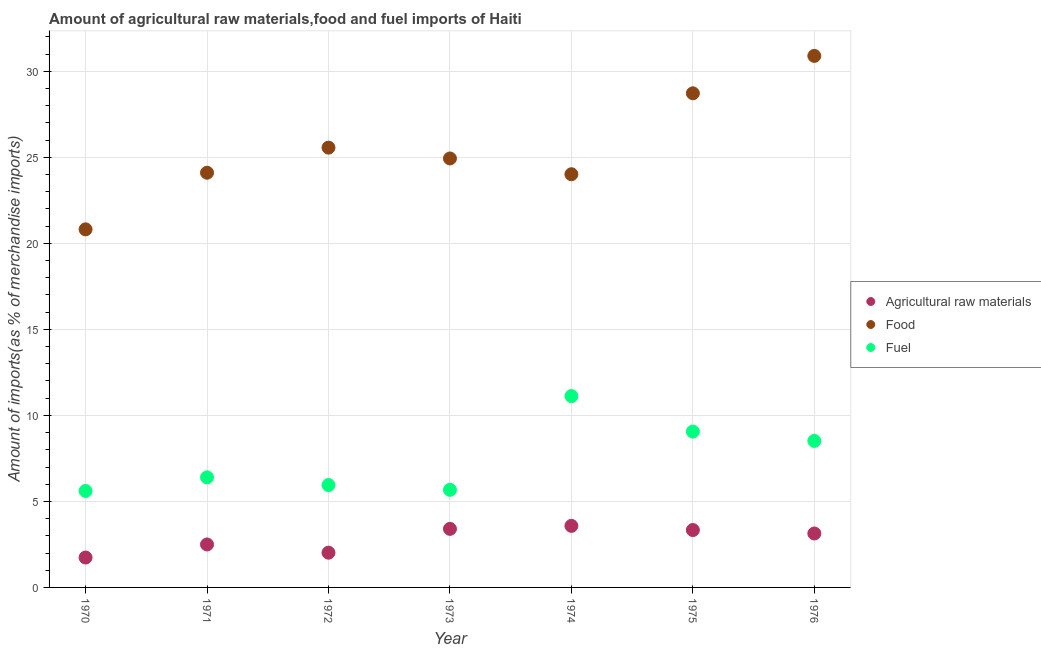How many different coloured dotlines are there?
Your answer should be compact. 3. What is the percentage of fuel imports in 1973?
Your answer should be compact. 5.67. Across all years, what is the maximum percentage of food imports?
Ensure brevity in your answer.  30.9. Across all years, what is the minimum percentage of food imports?
Your answer should be very brief. 20.81. In which year was the percentage of food imports maximum?
Your answer should be very brief. 1976. What is the total percentage of raw materials imports in the graph?
Provide a short and direct response. 19.71. What is the difference between the percentage of fuel imports in 1970 and that in 1974?
Provide a short and direct response. -5.51. What is the difference between the percentage of fuel imports in 1974 and the percentage of raw materials imports in 1973?
Give a very brief answer. 7.72. What is the average percentage of raw materials imports per year?
Keep it short and to the point. 2.82. In the year 1970, what is the difference between the percentage of fuel imports and percentage of raw materials imports?
Provide a succinct answer. 3.87. In how many years, is the percentage of raw materials imports greater than 6 %?
Offer a terse response. 0. What is the ratio of the percentage of food imports in 1973 to that in 1975?
Offer a very short reply. 0.87. What is the difference between the highest and the second highest percentage of food imports?
Your response must be concise. 2.17. What is the difference between the highest and the lowest percentage of raw materials imports?
Make the answer very short. 1.84. In how many years, is the percentage of food imports greater than the average percentage of food imports taken over all years?
Give a very brief answer. 2. Does the percentage of food imports monotonically increase over the years?
Keep it short and to the point. No. Is the percentage of food imports strictly less than the percentage of fuel imports over the years?
Keep it short and to the point. No. Are the values on the major ticks of Y-axis written in scientific E-notation?
Ensure brevity in your answer.  No. Where does the legend appear in the graph?
Make the answer very short. Center right. How many legend labels are there?
Offer a very short reply. 3. How are the legend labels stacked?
Your answer should be very brief. Vertical. What is the title of the graph?
Your answer should be compact. Amount of agricultural raw materials,food and fuel imports of Haiti. What is the label or title of the X-axis?
Your answer should be compact. Year. What is the label or title of the Y-axis?
Provide a short and direct response. Amount of imports(as % of merchandise imports). What is the Amount of imports(as % of merchandise imports) in Agricultural raw materials in 1970?
Make the answer very short. 1.74. What is the Amount of imports(as % of merchandise imports) of Food in 1970?
Keep it short and to the point. 20.81. What is the Amount of imports(as % of merchandise imports) in Fuel in 1970?
Ensure brevity in your answer.  5.61. What is the Amount of imports(as % of merchandise imports) of Agricultural raw materials in 1971?
Give a very brief answer. 2.5. What is the Amount of imports(as % of merchandise imports) in Food in 1971?
Provide a succinct answer. 24.11. What is the Amount of imports(as % of merchandise imports) in Fuel in 1971?
Give a very brief answer. 6.4. What is the Amount of imports(as % of merchandise imports) in Agricultural raw materials in 1972?
Offer a very short reply. 2.02. What is the Amount of imports(as % of merchandise imports) in Food in 1972?
Offer a terse response. 25.56. What is the Amount of imports(as % of merchandise imports) in Fuel in 1972?
Keep it short and to the point. 5.95. What is the Amount of imports(as % of merchandise imports) in Agricultural raw materials in 1973?
Make the answer very short. 3.4. What is the Amount of imports(as % of merchandise imports) in Food in 1973?
Your answer should be compact. 24.94. What is the Amount of imports(as % of merchandise imports) in Fuel in 1973?
Make the answer very short. 5.67. What is the Amount of imports(as % of merchandise imports) of Agricultural raw materials in 1974?
Ensure brevity in your answer.  3.58. What is the Amount of imports(as % of merchandise imports) in Food in 1974?
Provide a succinct answer. 24.02. What is the Amount of imports(as % of merchandise imports) in Fuel in 1974?
Ensure brevity in your answer.  11.12. What is the Amount of imports(as % of merchandise imports) of Agricultural raw materials in 1975?
Keep it short and to the point. 3.34. What is the Amount of imports(as % of merchandise imports) in Food in 1975?
Keep it short and to the point. 28.72. What is the Amount of imports(as % of merchandise imports) of Fuel in 1975?
Your answer should be very brief. 9.06. What is the Amount of imports(as % of merchandise imports) in Agricultural raw materials in 1976?
Offer a terse response. 3.14. What is the Amount of imports(as % of merchandise imports) in Food in 1976?
Give a very brief answer. 30.9. What is the Amount of imports(as % of merchandise imports) of Fuel in 1976?
Offer a very short reply. 8.52. Across all years, what is the maximum Amount of imports(as % of merchandise imports) in Agricultural raw materials?
Provide a short and direct response. 3.58. Across all years, what is the maximum Amount of imports(as % of merchandise imports) in Food?
Keep it short and to the point. 30.9. Across all years, what is the maximum Amount of imports(as % of merchandise imports) in Fuel?
Your answer should be compact. 11.12. Across all years, what is the minimum Amount of imports(as % of merchandise imports) in Agricultural raw materials?
Your answer should be very brief. 1.74. Across all years, what is the minimum Amount of imports(as % of merchandise imports) of Food?
Make the answer very short. 20.81. Across all years, what is the minimum Amount of imports(as % of merchandise imports) of Fuel?
Provide a short and direct response. 5.61. What is the total Amount of imports(as % of merchandise imports) in Agricultural raw materials in the graph?
Your answer should be compact. 19.71. What is the total Amount of imports(as % of merchandise imports) of Food in the graph?
Make the answer very short. 179.06. What is the total Amount of imports(as % of merchandise imports) of Fuel in the graph?
Your response must be concise. 52.33. What is the difference between the Amount of imports(as % of merchandise imports) in Agricultural raw materials in 1970 and that in 1971?
Ensure brevity in your answer.  -0.76. What is the difference between the Amount of imports(as % of merchandise imports) of Food in 1970 and that in 1971?
Your response must be concise. -3.29. What is the difference between the Amount of imports(as % of merchandise imports) of Fuel in 1970 and that in 1971?
Your answer should be compact. -0.79. What is the difference between the Amount of imports(as % of merchandise imports) of Agricultural raw materials in 1970 and that in 1972?
Keep it short and to the point. -0.28. What is the difference between the Amount of imports(as % of merchandise imports) in Food in 1970 and that in 1972?
Keep it short and to the point. -4.75. What is the difference between the Amount of imports(as % of merchandise imports) of Fuel in 1970 and that in 1972?
Your answer should be very brief. -0.34. What is the difference between the Amount of imports(as % of merchandise imports) of Agricultural raw materials in 1970 and that in 1973?
Make the answer very short. -1.67. What is the difference between the Amount of imports(as % of merchandise imports) in Food in 1970 and that in 1973?
Your answer should be very brief. -4.12. What is the difference between the Amount of imports(as % of merchandise imports) in Fuel in 1970 and that in 1973?
Ensure brevity in your answer.  -0.07. What is the difference between the Amount of imports(as % of merchandise imports) in Agricultural raw materials in 1970 and that in 1974?
Provide a succinct answer. -1.84. What is the difference between the Amount of imports(as % of merchandise imports) in Food in 1970 and that in 1974?
Keep it short and to the point. -3.2. What is the difference between the Amount of imports(as % of merchandise imports) in Fuel in 1970 and that in 1974?
Keep it short and to the point. -5.51. What is the difference between the Amount of imports(as % of merchandise imports) of Agricultural raw materials in 1970 and that in 1975?
Give a very brief answer. -1.6. What is the difference between the Amount of imports(as % of merchandise imports) in Food in 1970 and that in 1975?
Offer a very short reply. -7.91. What is the difference between the Amount of imports(as % of merchandise imports) in Fuel in 1970 and that in 1975?
Make the answer very short. -3.45. What is the difference between the Amount of imports(as % of merchandise imports) of Agricultural raw materials in 1970 and that in 1976?
Offer a very short reply. -1.4. What is the difference between the Amount of imports(as % of merchandise imports) of Food in 1970 and that in 1976?
Your response must be concise. -10.08. What is the difference between the Amount of imports(as % of merchandise imports) of Fuel in 1970 and that in 1976?
Ensure brevity in your answer.  -2.91. What is the difference between the Amount of imports(as % of merchandise imports) in Agricultural raw materials in 1971 and that in 1972?
Offer a very short reply. 0.48. What is the difference between the Amount of imports(as % of merchandise imports) in Food in 1971 and that in 1972?
Offer a terse response. -1.46. What is the difference between the Amount of imports(as % of merchandise imports) of Fuel in 1971 and that in 1972?
Offer a terse response. 0.45. What is the difference between the Amount of imports(as % of merchandise imports) of Agricultural raw materials in 1971 and that in 1973?
Offer a very short reply. -0.91. What is the difference between the Amount of imports(as % of merchandise imports) in Food in 1971 and that in 1973?
Ensure brevity in your answer.  -0.83. What is the difference between the Amount of imports(as % of merchandise imports) of Fuel in 1971 and that in 1973?
Your answer should be very brief. 0.72. What is the difference between the Amount of imports(as % of merchandise imports) in Agricultural raw materials in 1971 and that in 1974?
Your response must be concise. -1.08. What is the difference between the Amount of imports(as % of merchandise imports) in Food in 1971 and that in 1974?
Offer a very short reply. 0.09. What is the difference between the Amount of imports(as % of merchandise imports) in Fuel in 1971 and that in 1974?
Offer a terse response. -4.73. What is the difference between the Amount of imports(as % of merchandise imports) of Agricultural raw materials in 1971 and that in 1975?
Your answer should be very brief. -0.84. What is the difference between the Amount of imports(as % of merchandise imports) of Food in 1971 and that in 1975?
Keep it short and to the point. -4.62. What is the difference between the Amount of imports(as % of merchandise imports) in Fuel in 1971 and that in 1975?
Offer a very short reply. -2.66. What is the difference between the Amount of imports(as % of merchandise imports) of Agricultural raw materials in 1971 and that in 1976?
Provide a succinct answer. -0.64. What is the difference between the Amount of imports(as % of merchandise imports) in Food in 1971 and that in 1976?
Keep it short and to the point. -6.79. What is the difference between the Amount of imports(as % of merchandise imports) in Fuel in 1971 and that in 1976?
Give a very brief answer. -2.12. What is the difference between the Amount of imports(as % of merchandise imports) in Agricultural raw materials in 1972 and that in 1973?
Offer a very short reply. -1.39. What is the difference between the Amount of imports(as % of merchandise imports) of Food in 1972 and that in 1973?
Keep it short and to the point. 0.63. What is the difference between the Amount of imports(as % of merchandise imports) in Fuel in 1972 and that in 1973?
Offer a terse response. 0.28. What is the difference between the Amount of imports(as % of merchandise imports) of Agricultural raw materials in 1972 and that in 1974?
Provide a succinct answer. -1.56. What is the difference between the Amount of imports(as % of merchandise imports) of Food in 1972 and that in 1974?
Your answer should be compact. 1.55. What is the difference between the Amount of imports(as % of merchandise imports) in Fuel in 1972 and that in 1974?
Your answer should be very brief. -5.17. What is the difference between the Amount of imports(as % of merchandise imports) of Agricultural raw materials in 1972 and that in 1975?
Offer a terse response. -1.32. What is the difference between the Amount of imports(as % of merchandise imports) in Food in 1972 and that in 1975?
Keep it short and to the point. -3.16. What is the difference between the Amount of imports(as % of merchandise imports) of Fuel in 1972 and that in 1975?
Provide a succinct answer. -3.11. What is the difference between the Amount of imports(as % of merchandise imports) in Agricultural raw materials in 1972 and that in 1976?
Your response must be concise. -1.12. What is the difference between the Amount of imports(as % of merchandise imports) of Food in 1972 and that in 1976?
Your answer should be compact. -5.33. What is the difference between the Amount of imports(as % of merchandise imports) of Fuel in 1972 and that in 1976?
Keep it short and to the point. -2.57. What is the difference between the Amount of imports(as % of merchandise imports) of Agricultural raw materials in 1973 and that in 1974?
Offer a very short reply. -0.17. What is the difference between the Amount of imports(as % of merchandise imports) of Food in 1973 and that in 1974?
Your response must be concise. 0.92. What is the difference between the Amount of imports(as % of merchandise imports) of Fuel in 1973 and that in 1974?
Keep it short and to the point. -5.45. What is the difference between the Amount of imports(as % of merchandise imports) of Agricultural raw materials in 1973 and that in 1975?
Your answer should be very brief. 0.07. What is the difference between the Amount of imports(as % of merchandise imports) of Food in 1973 and that in 1975?
Make the answer very short. -3.79. What is the difference between the Amount of imports(as % of merchandise imports) of Fuel in 1973 and that in 1975?
Make the answer very short. -3.39. What is the difference between the Amount of imports(as % of merchandise imports) of Agricultural raw materials in 1973 and that in 1976?
Give a very brief answer. 0.27. What is the difference between the Amount of imports(as % of merchandise imports) of Food in 1973 and that in 1976?
Your answer should be compact. -5.96. What is the difference between the Amount of imports(as % of merchandise imports) in Fuel in 1973 and that in 1976?
Offer a very short reply. -2.84. What is the difference between the Amount of imports(as % of merchandise imports) of Agricultural raw materials in 1974 and that in 1975?
Your answer should be compact. 0.24. What is the difference between the Amount of imports(as % of merchandise imports) in Food in 1974 and that in 1975?
Ensure brevity in your answer.  -4.7. What is the difference between the Amount of imports(as % of merchandise imports) in Fuel in 1974 and that in 1975?
Make the answer very short. 2.06. What is the difference between the Amount of imports(as % of merchandise imports) in Agricultural raw materials in 1974 and that in 1976?
Provide a succinct answer. 0.44. What is the difference between the Amount of imports(as % of merchandise imports) of Food in 1974 and that in 1976?
Ensure brevity in your answer.  -6.88. What is the difference between the Amount of imports(as % of merchandise imports) in Fuel in 1974 and that in 1976?
Offer a terse response. 2.61. What is the difference between the Amount of imports(as % of merchandise imports) of Agricultural raw materials in 1975 and that in 1976?
Keep it short and to the point. 0.2. What is the difference between the Amount of imports(as % of merchandise imports) in Food in 1975 and that in 1976?
Keep it short and to the point. -2.17. What is the difference between the Amount of imports(as % of merchandise imports) in Fuel in 1975 and that in 1976?
Give a very brief answer. 0.54. What is the difference between the Amount of imports(as % of merchandise imports) in Agricultural raw materials in 1970 and the Amount of imports(as % of merchandise imports) in Food in 1971?
Give a very brief answer. -22.37. What is the difference between the Amount of imports(as % of merchandise imports) of Agricultural raw materials in 1970 and the Amount of imports(as % of merchandise imports) of Fuel in 1971?
Provide a short and direct response. -4.66. What is the difference between the Amount of imports(as % of merchandise imports) of Food in 1970 and the Amount of imports(as % of merchandise imports) of Fuel in 1971?
Provide a succinct answer. 14.42. What is the difference between the Amount of imports(as % of merchandise imports) in Agricultural raw materials in 1970 and the Amount of imports(as % of merchandise imports) in Food in 1972?
Give a very brief answer. -23.83. What is the difference between the Amount of imports(as % of merchandise imports) in Agricultural raw materials in 1970 and the Amount of imports(as % of merchandise imports) in Fuel in 1972?
Keep it short and to the point. -4.21. What is the difference between the Amount of imports(as % of merchandise imports) in Food in 1970 and the Amount of imports(as % of merchandise imports) in Fuel in 1972?
Give a very brief answer. 14.86. What is the difference between the Amount of imports(as % of merchandise imports) of Agricultural raw materials in 1970 and the Amount of imports(as % of merchandise imports) of Food in 1973?
Offer a terse response. -23.2. What is the difference between the Amount of imports(as % of merchandise imports) of Agricultural raw materials in 1970 and the Amount of imports(as % of merchandise imports) of Fuel in 1973?
Your answer should be compact. -3.94. What is the difference between the Amount of imports(as % of merchandise imports) of Food in 1970 and the Amount of imports(as % of merchandise imports) of Fuel in 1973?
Offer a very short reply. 15.14. What is the difference between the Amount of imports(as % of merchandise imports) in Agricultural raw materials in 1970 and the Amount of imports(as % of merchandise imports) in Food in 1974?
Your answer should be very brief. -22.28. What is the difference between the Amount of imports(as % of merchandise imports) of Agricultural raw materials in 1970 and the Amount of imports(as % of merchandise imports) of Fuel in 1974?
Your answer should be compact. -9.38. What is the difference between the Amount of imports(as % of merchandise imports) in Food in 1970 and the Amount of imports(as % of merchandise imports) in Fuel in 1974?
Provide a succinct answer. 9.69. What is the difference between the Amount of imports(as % of merchandise imports) of Agricultural raw materials in 1970 and the Amount of imports(as % of merchandise imports) of Food in 1975?
Keep it short and to the point. -26.98. What is the difference between the Amount of imports(as % of merchandise imports) in Agricultural raw materials in 1970 and the Amount of imports(as % of merchandise imports) in Fuel in 1975?
Give a very brief answer. -7.32. What is the difference between the Amount of imports(as % of merchandise imports) in Food in 1970 and the Amount of imports(as % of merchandise imports) in Fuel in 1975?
Provide a short and direct response. 11.75. What is the difference between the Amount of imports(as % of merchandise imports) of Agricultural raw materials in 1970 and the Amount of imports(as % of merchandise imports) of Food in 1976?
Offer a very short reply. -29.16. What is the difference between the Amount of imports(as % of merchandise imports) of Agricultural raw materials in 1970 and the Amount of imports(as % of merchandise imports) of Fuel in 1976?
Your answer should be compact. -6.78. What is the difference between the Amount of imports(as % of merchandise imports) of Food in 1970 and the Amount of imports(as % of merchandise imports) of Fuel in 1976?
Provide a succinct answer. 12.3. What is the difference between the Amount of imports(as % of merchandise imports) in Agricultural raw materials in 1971 and the Amount of imports(as % of merchandise imports) in Food in 1972?
Keep it short and to the point. -23.07. What is the difference between the Amount of imports(as % of merchandise imports) of Agricultural raw materials in 1971 and the Amount of imports(as % of merchandise imports) of Fuel in 1972?
Offer a terse response. -3.45. What is the difference between the Amount of imports(as % of merchandise imports) in Food in 1971 and the Amount of imports(as % of merchandise imports) in Fuel in 1972?
Offer a terse response. 18.16. What is the difference between the Amount of imports(as % of merchandise imports) in Agricultural raw materials in 1971 and the Amount of imports(as % of merchandise imports) in Food in 1973?
Provide a short and direct response. -22.44. What is the difference between the Amount of imports(as % of merchandise imports) in Agricultural raw materials in 1971 and the Amount of imports(as % of merchandise imports) in Fuel in 1973?
Make the answer very short. -3.18. What is the difference between the Amount of imports(as % of merchandise imports) of Food in 1971 and the Amount of imports(as % of merchandise imports) of Fuel in 1973?
Ensure brevity in your answer.  18.43. What is the difference between the Amount of imports(as % of merchandise imports) in Agricultural raw materials in 1971 and the Amount of imports(as % of merchandise imports) in Food in 1974?
Your response must be concise. -21.52. What is the difference between the Amount of imports(as % of merchandise imports) of Agricultural raw materials in 1971 and the Amount of imports(as % of merchandise imports) of Fuel in 1974?
Provide a short and direct response. -8.63. What is the difference between the Amount of imports(as % of merchandise imports) of Food in 1971 and the Amount of imports(as % of merchandise imports) of Fuel in 1974?
Give a very brief answer. 12.98. What is the difference between the Amount of imports(as % of merchandise imports) of Agricultural raw materials in 1971 and the Amount of imports(as % of merchandise imports) of Food in 1975?
Keep it short and to the point. -26.23. What is the difference between the Amount of imports(as % of merchandise imports) of Agricultural raw materials in 1971 and the Amount of imports(as % of merchandise imports) of Fuel in 1975?
Keep it short and to the point. -6.56. What is the difference between the Amount of imports(as % of merchandise imports) of Food in 1971 and the Amount of imports(as % of merchandise imports) of Fuel in 1975?
Keep it short and to the point. 15.05. What is the difference between the Amount of imports(as % of merchandise imports) in Agricultural raw materials in 1971 and the Amount of imports(as % of merchandise imports) in Food in 1976?
Provide a short and direct response. -28.4. What is the difference between the Amount of imports(as % of merchandise imports) in Agricultural raw materials in 1971 and the Amount of imports(as % of merchandise imports) in Fuel in 1976?
Provide a succinct answer. -6.02. What is the difference between the Amount of imports(as % of merchandise imports) in Food in 1971 and the Amount of imports(as % of merchandise imports) in Fuel in 1976?
Make the answer very short. 15.59. What is the difference between the Amount of imports(as % of merchandise imports) of Agricultural raw materials in 1972 and the Amount of imports(as % of merchandise imports) of Food in 1973?
Provide a short and direct response. -22.92. What is the difference between the Amount of imports(as % of merchandise imports) in Agricultural raw materials in 1972 and the Amount of imports(as % of merchandise imports) in Fuel in 1973?
Your response must be concise. -3.65. What is the difference between the Amount of imports(as % of merchandise imports) in Food in 1972 and the Amount of imports(as % of merchandise imports) in Fuel in 1973?
Give a very brief answer. 19.89. What is the difference between the Amount of imports(as % of merchandise imports) in Agricultural raw materials in 1972 and the Amount of imports(as % of merchandise imports) in Food in 1974?
Provide a short and direct response. -22. What is the difference between the Amount of imports(as % of merchandise imports) of Agricultural raw materials in 1972 and the Amount of imports(as % of merchandise imports) of Fuel in 1974?
Provide a succinct answer. -9.1. What is the difference between the Amount of imports(as % of merchandise imports) of Food in 1972 and the Amount of imports(as % of merchandise imports) of Fuel in 1974?
Give a very brief answer. 14.44. What is the difference between the Amount of imports(as % of merchandise imports) of Agricultural raw materials in 1972 and the Amount of imports(as % of merchandise imports) of Food in 1975?
Provide a succinct answer. -26.7. What is the difference between the Amount of imports(as % of merchandise imports) in Agricultural raw materials in 1972 and the Amount of imports(as % of merchandise imports) in Fuel in 1975?
Make the answer very short. -7.04. What is the difference between the Amount of imports(as % of merchandise imports) in Food in 1972 and the Amount of imports(as % of merchandise imports) in Fuel in 1975?
Offer a terse response. 16.5. What is the difference between the Amount of imports(as % of merchandise imports) of Agricultural raw materials in 1972 and the Amount of imports(as % of merchandise imports) of Food in 1976?
Provide a short and direct response. -28.88. What is the difference between the Amount of imports(as % of merchandise imports) of Agricultural raw materials in 1972 and the Amount of imports(as % of merchandise imports) of Fuel in 1976?
Keep it short and to the point. -6.5. What is the difference between the Amount of imports(as % of merchandise imports) of Food in 1972 and the Amount of imports(as % of merchandise imports) of Fuel in 1976?
Provide a succinct answer. 17.05. What is the difference between the Amount of imports(as % of merchandise imports) in Agricultural raw materials in 1973 and the Amount of imports(as % of merchandise imports) in Food in 1974?
Offer a terse response. -20.62. What is the difference between the Amount of imports(as % of merchandise imports) in Agricultural raw materials in 1973 and the Amount of imports(as % of merchandise imports) in Fuel in 1974?
Your answer should be very brief. -7.72. What is the difference between the Amount of imports(as % of merchandise imports) of Food in 1973 and the Amount of imports(as % of merchandise imports) of Fuel in 1974?
Give a very brief answer. 13.81. What is the difference between the Amount of imports(as % of merchandise imports) of Agricultural raw materials in 1973 and the Amount of imports(as % of merchandise imports) of Food in 1975?
Your answer should be compact. -25.32. What is the difference between the Amount of imports(as % of merchandise imports) of Agricultural raw materials in 1973 and the Amount of imports(as % of merchandise imports) of Fuel in 1975?
Your response must be concise. -5.66. What is the difference between the Amount of imports(as % of merchandise imports) in Food in 1973 and the Amount of imports(as % of merchandise imports) in Fuel in 1975?
Provide a short and direct response. 15.88. What is the difference between the Amount of imports(as % of merchandise imports) in Agricultural raw materials in 1973 and the Amount of imports(as % of merchandise imports) in Food in 1976?
Offer a very short reply. -27.49. What is the difference between the Amount of imports(as % of merchandise imports) of Agricultural raw materials in 1973 and the Amount of imports(as % of merchandise imports) of Fuel in 1976?
Keep it short and to the point. -5.11. What is the difference between the Amount of imports(as % of merchandise imports) in Food in 1973 and the Amount of imports(as % of merchandise imports) in Fuel in 1976?
Offer a very short reply. 16.42. What is the difference between the Amount of imports(as % of merchandise imports) of Agricultural raw materials in 1974 and the Amount of imports(as % of merchandise imports) of Food in 1975?
Give a very brief answer. -25.14. What is the difference between the Amount of imports(as % of merchandise imports) in Agricultural raw materials in 1974 and the Amount of imports(as % of merchandise imports) in Fuel in 1975?
Provide a short and direct response. -5.48. What is the difference between the Amount of imports(as % of merchandise imports) in Food in 1974 and the Amount of imports(as % of merchandise imports) in Fuel in 1975?
Give a very brief answer. 14.96. What is the difference between the Amount of imports(as % of merchandise imports) in Agricultural raw materials in 1974 and the Amount of imports(as % of merchandise imports) in Food in 1976?
Make the answer very short. -27.32. What is the difference between the Amount of imports(as % of merchandise imports) of Agricultural raw materials in 1974 and the Amount of imports(as % of merchandise imports) of Fuel in 1976?
Provide a short and direct response. -4.94. What is the difference between the Amount of imports(as % of merchandise imports) of Food in 1974 and the Amount of imports(as % of merchandise imports) of Fuel in 1976?
Provide a short and direct response. 15.5. What is the difference between the Amount of imports(as % of merchandise imports) in Agricultural raw materials in 1975 and the Amount of imports(as % of merchandise imports) in Food in 1976?
Your answer should be very brief. -27.56. What is the difference between the Amount of imports(as % of merchandise imports) in Agricultural raw materials in 1975 and the Amount of imports(as % of merchandise imports) in Fuel in 1976?
Provide a short and direct response. -5.18. What is the difference between the Amount of imports(as % of merchandise imports) in Food in 1975 and the Amount of imports(as % of merchandise imports) in Fuel in 1976?
Ensure brevity in your answer.  20.21. What is the average Amount of imports(as % of merchandise imports) in Agricultural raw materials per year?
Offer a very short reply. 2.82. What is the average Amount of imports(as % of merchandise imports) of Food per year?
Make the answer very short. 25.58. What is the average Amount of imports(as % of merchandise imports) of Fuel per year?
Your answer should be compact. 7.48. In the year 1970, what is the difference between the Amount of imports(as % of merchandise imports) in Agricultural raw materials and Amount of imports(as % of merchandise imports) in Food?
Make the answer very short. -19.08. In the year 1970, what is the difference between the Amount of imports(as % of merchandise imports) in Agricultural raw materials and Amount of imports(as % of merchandise imports) in Fuel?
Offer a terse response. -3.87. In the year 1970, what is the difference between the Amount of imports(as % of merchandise imports) of Food and Amount of imports(as % of merchandise imports) of Fuel?
Make the answer very short. 15.21. In the year 1971, what is the difference between the Amount of imports(as % of merchandise imports) in Agricultural raw materials and Amount of imports(as % of merchandise imports) in Food?
Your answer should be compact. -21.61. In the year 1971, what is the difference between the Amount of imports(as % of merchandise imports) of Agricultural raw materials and Amount of imports(as % of merchandise imports) of Fuel?
Make the answer very short. -3.9. In the year 1971, what is the difference between the Amount of imports(as % of merchandise imports) in Food and Amount of imports(as % of merchandise imports) in Fuel?
Keep it short and to the point. 17.71. In the year 1972, what is the difference between the Amount of imports(as % of merchandise imports) of Agricultural raw materials and Amount of imports(as % of merchandise imports) of Food?
Provide a short and direct response. -23.55. In the year 1972, what is the difference between the Amount of imports(as % of merchandise imports) in Agricultural raw materials and Amount of imports(as % of merchandise imports) in Fuel?
Provide a short and direct response. -3.93. In the year 1972, what is the difference between the Amount of imports(as % of merchandise imports) in Food and Amount of imports(as % of merchandise imports) in Fuel?
Your response must be concise. 19.61. In the year 1973, what is the difference between the Amount of imports(as % of merchandise imports) in Agricultural raw materials and Amount of imports(as % of merchandise imports) in Food?
Ensure brevity in your answer.  -21.53. In the year 1973, what is the difference between the Amount of imports(as % of merchandise imports) in Agricultural raw materials and Amount of imports(as % of merchandise imports) in Fuel?
Your response must be concise. -2.27. In the year 1973, what is the difference between the Amount of imports(as % of merchandise imports) of Food and Amount of imports(as % of merchandise imports) of Fuel?
Keep it short and to the point. 19.26. In the year 1974, what is the difference between the Amount of imports(as % of merchandise imports) in Agricultural raw materials and Amount of imports(as % of merchandise imports) in Food?
Keep it short and to the point. -20.44. In the year 1974, what is the difference between the Amount of imports(as % of merchandise imports) in Agricultural raw materials and Amount of imports(as % of merchandise imports) in Fuel?
Make the answer very short. -7.54. In the year 1974, what is the difference between the Amount of imports(as % of merchandise imports) of Food and Amount of imports(as % of merchandise imports) of Fuel?
Your answer should be very brief. 12.9. In the year 1975, what is the difference between the Amount of imports(as % of merchandise imports) in Agricultural raw materials and Amount of imports(as % of merchandise imports) in Food?
Your answer should be compact. -25.39. In the year 1975, what is the difference between the Amount of imports(as % of merchandise imports) of Agricultural raw materials and Amount of imports(as % of merchandise imports) of Fuel?
Your answer should be compact. -5.72. In the year 1975, what is the difference between the Amount of imports(as % of merchandise imports) of Food and Amount of imports(as % of merchandise imports) of Fuel?
Make the answer very short. 19.66. In the year 1976, what is the difference between the Amount of imports(as % of merchandise imports) of Agricultural raw materials and Amount of imports(as % of merchandise imports) of Food?
Offer a terse response. -27.76. In the year 1976, what is the difference between the Amount of imports(as % of merchandise imports) of Agricultural raw materials and Amount of imports(as % of merchandise imports) of Fuel?
Offer a terse response. -5.38. In the year 1976, what is the difference between the Amount of imports(as % of merchandise imports) of Food and Amount of imports(as % of merchandise imports) of Fuel?
Ensure brevity in your answer.  22.38. What is the ratio of the Amount of imports(as % of merchandise imports) in Agricultural raw materials in 1970 to that in 1971?
Provide a short and direct response. 0.7. What is the ratio of the Amount of imports(as % of merchandise imports) in Food in 1970 to that in 1971?
Your response must be concise. 0.86. What is the ratio of the Amount of imports(as % of merchandise imports) in Fuel in 1970 to that in 1971?
Provide a short and direct response. 0.88. What is the ratio of the Amount of imports(as % of merchandise imports) in Agricultural raw materials in 1970 to that in 1972?
Your answer should be compact. 0.86. What is the ratio of the Amount of imports(as % of merchandise imports) in Food in 1970 to that in 1972?
Provide a short and direct response. 0.81. What is the ratio of the Amount of imports(as % of merchandise imports) of Fuel in 1970 to that in 1972?
Make the answer very short. 0.94. What is the ratio of the Amount of imports(as % of merchandise imports) of Agricultural raw materials in 1970 to that in 1973?
Ensure brevity in your answer.  0.51. What is the ratio of the Amount of imports(as % of merchandise imports) in Food in 1970 to that in 1973?
Provide a succinct answer. 0.83. What is the ratio of the Amount of imports(as % of merchandise imports) in Fuel in 1970 to that in 1973?
Offer a terse response. 0.99. What is the ratio of the Amount of imports(as % of merchandise imports) in Agricultural raw materials in 1970 to that in 1974?
Your answer should be very brief. 0.49. What is the ratio of the Amount of imports(as % of merchandise imports) in Food in 1970 to that in 1974?
Give a very brief answer. 0.87. What is the ratio of the Amount of imports(as % of merchandise imports) of Fuel in 1970 to that in 1974?
Provide a short and direct response. 0.5. What is the ratio of the Amount of imports(as % of merchandise imports) in Agricultural raw materials in 1970 to that in 1975?
Keep it short and to the point. 0.52. What is the ratio of the Amount of imports(as % of merchandise imports) of Food in 1970 to that in 1975?
Provide a short and direct response. 0.72. What is the ratio of the Amount of imports(as % of merchandise imports) in Fuel in 1970 to that in 1975?
Provide a short and direct response. 0.62. What is the ratio of the Amount of imports(as % of merchandise imports) of Agricultural raw materials in 1970 to that in 1976?
Give a very brief answer. 0.55. What is the ratio of the Amount of imports(as % of merchandise imports) of Food in 1970 to that in 1976?
Ensure brevity in your answer.  0.67. What is the ratio of the Amount of imports(as % of merchandise imports) in Fuel in 1970 to that in 1976?
Your answer should be very brief. 0.66. What is the ratio of the Amount of imports(as % of merchandise imports) in Agricultural raw materials in 1971 to that in 1972?
Give a very brief answer. 1.24. What is the ratio of the Amount of imports(as % of merchandise imports) in Food in 1971 to that in 1972?
Your answer should be compact. 0.94. What is the ratio of the Amount of imports(as % of merchandise imports) of Fuel in 1971 to that in 1972?
Provide a succinct answer. 1.07. What is the ratio of the Amount of imports(as % of merchandise imports) in Agricultural raw materials in 1971 to that in 1973?
Ensure brevity in your answer.  0.73. What is the ratio of the Amount of imports(as % of merchandise imports) in Food in 1971 to that in 1973?
Provide a succinct answer. 0.97. What is the ratio of the Amount of imports(as % of merchandise imports) in Fuel in 1971 to that in 1973?
Keep it short and to the point. 1.13. What is the ratio of the Amount of imports(as % of merchandise imports) in Agricultural raw materials in 1971 to that in 1974?
Provide a short and direct response. 0.7. What is the ratio of the Amount of imports(as % of merchandise imports) in Food in 1971 to that in 1974?
Your response must be concise. 1. What is the ratio of the Amount of imports(as % of merchandise imports) of Fuel in 1971 to that in 1974?
Ensure brevity in your answer.  0.58. What is the ratio of the Amount of imports(as % of merchandise imports) of Agricultural raw materials in 1971 to that in 1975?
Make the answer very short. 0.75. What is the ratio of the Amount of imports(as % of merchandise imports) of Food in 1971 to that in 1975?
Make the answer very short. 0.84. What is the ratio of the Amount of imports(as % of merchandise imports) of Fuel in 1971 to that in 1975?
Ensure brevity in your answer.  0.71. What is the ratio of the Amount of imports(as % of merchandise imports) of Agricultural raw materials in 1971 to that in 1976?
Your answer should be very brief. 0.8. What is the ratio of the Amount of imports(as % of merchandise imports) of Food in 1971 to that in 1976?
Keep it short and to the point. 0.78. What is the ratio of the Amount of imports(as % of merchandise imports) in Fuel in 1971 to that in 1976?
Your answer should be very brief. 0.75. What is the ratio of the Amount of imports(as % of merchandise imports) in Agricultural raw materials in 1972 to that in 1973?
Your answer should be very brief. 0.59. What is the ratio of the Amount of imports(as % of merchandise imports) of Food in 1972 to that in 1973?
Your answer should be compact. 1.03. What is the ratio of the Amount of imports(as % of merchandise imports) in Fuel in 1972 to that in 1973?
Your answer should be very brief. 1.05. What is the ratio of the Amount of imports(as % of merchandise imports) of Agricultural raw materials in 1972 to that in 1974?
Offer a terse response. 0.56. What is the ratio of the Amount of imports(as % of merchandise imports) of Food in 1972 to that in 1974?
Make the answer very short. 1.06. What is the ratio of the Amount of imports(as % of merchandise imports) in Fuel in 1972 to that in 1974?
Offer a very short reply. 0.54. What is the ratio of the Amount of imports(as % of merchandise imports) in Agricultural raw materials in 1972 to that in 1975?
Keep it short and to the point. 0.61. What is the ratio of the Amount of imports(as % of merchandise imports) in Food in 1972 to that in 1975?
Offer a terse response. 0.89. What is the ratio of the Amount of imports(as % of merchandise imports) of Fuel in 1972 to that in 1975?
Your response must be concise. 0.66. What is the ratio of the Amount of imports(as % of merchandise imports) in Agricultural raw materials in 1972 to that in 1976?
Give a very brief answer. 0.64. What is the ratio of the Amount of imports(as % of merchandise imports) in Food in 1972 to that in 1976?
Keep it short and to the point. 0.83. What is the ratio of the Amount of imports(as % of merchandise imports) of Fuel in 1972 to that in 1976?
Keep it short and to the point. 0.7. What is the ratio of the Amount of imports(as % of merchandise imports) of Agricultural raw materials in 1973 to that in 1974?
Keep it short and to the point. 0.95. What is the ratio of the Amount of imports(as % of merchandise imports) in Food in 1973 to that in 1974?
Give a very brief answer. 1.04. What is the ratio of the Amount of imports(as % of merchandise imports) of Fuel in 1973 to that in 1974?
Keep it short and to the point. 0.51. What is the ratio of the Amount of imports(as % of merchandise imports) of Agricultural raw materials in 1973 to that in 1975?
Offer a very short reply. 1.02. What is the ratio of the Amount of imports(as % of merchandise imports) in Food in 1973 to that in 1975?
Make the answer very short. 0.87. What is the ratio of the Amount of imports(as % of merchandise imports) in Fuel in 1973 to that in 1975?
Your answer should be compact. 0.63. What is the ratio of the Amount of imports(as % of merchandise imports) of Agricultural raw materials in 1973 to that in 1976?
Provide a succinct answer. 1.09. What is the ratio of the Amount of imports(as % of merchandise imports) of Food in 1973 to that in 1976?
Your answer should be compact. 0.81. What is the ratio of the Amount of imports(as % of merchandise imports) in Fuel in 1973 to that in 1976?
Offer a very short reply. 0.67. What is the ratio of the Amount of imports(as % of merchandise imports) of Agricultural raw materials in 1974 to that in 1975?
Give a very brief answer. 1.07. What is the ratio of the Amount of imports(as % of merchandise imports) of Food in 1974 to that in 1975?
Provide a succinct answer. 0.84. What is the ratio of the Amount of imports(as % of merchandise imports) of Fuel in 1974 to that in 1975?
Your response must be concise. 1.23. What is the ratio of the Amount of imports(as % of merchandise imports) of Agricultural raw materials in 1974 to that in 1976?
Offer a terse response. 1.14. What is the ratio of the Amount of imports(as % of merchandise imports) in Food in 1974 to that in 1976?
Provide a succinct answer. 0.78. What is the ratio of the Amount of imports(as % of merchandise imports) of Fuel in 1974 to that in 1976?
Provide a succinct answer. 1.31. What is the ratio of the Amount of imports(as % of merchandise imports) of Agricultural raw materials in 1975 to that in 1976?
Your answer should be compact. 1.06. What is the ratio of the Amount of imports(as % of merchandise imports) in Food in 1975 to that in 1976?
Keep it short and to the point. 0.93. What is the ratio of the Amount of imports(as % of merchandise imports) of Fuel in 1975 to that in 1976?
Your response must be concise. 1.06. What is the difference between the highest and the second highest Amount of imports(as % of merchandise imports) of Agricultural raw materials?
Provide a succinct answer. 0.17. What is the difference between the highest and the second highest Amount of imports(as % of merchandise imports) of Food?
Your response must be concise. 2.17. What is the difference between the highest and the second highest Amount of imports(as % of merchandise imports) of Fuel?
Your answer should be compact. 2.06. What is the difference between the highest and the lowest Amount of imports(as % of merchandise imports) in Agricultural raw materials?
Your answer should be compact. 1.84. What is the difference between the highest and the lowest Amount of imports(as % of merchandise imports) in Food?
Keep it short and to the point. 10.08. What is the difference between the highest and the lowest Amount of imports(as % of merchandise imports) of Fuel?
Your answer should be very brief. 5.51. 